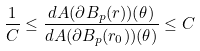<formula> <loc_0><loc_0><loc_500><loc_500>\frac { 1 } { C } \leq \frac { d A ( \partial B _ { p } ( r ) ) ( \theta ) } { d A ( \partial B _ { p } ( r _ { 0 } ) ) ( \theta ) } \leq C</formula> 